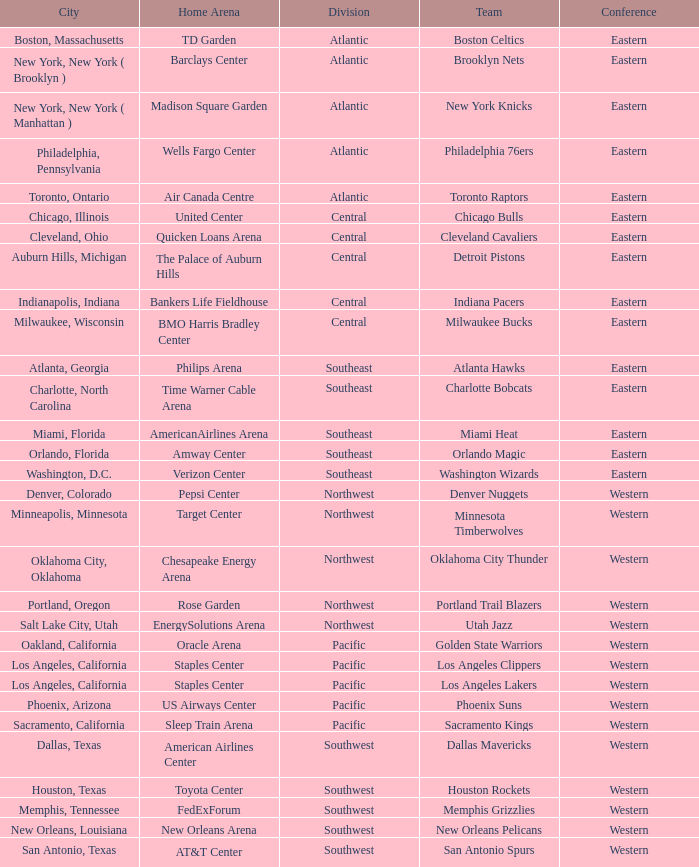Which division do the Toronto Raptors belong in? Atlantic. 